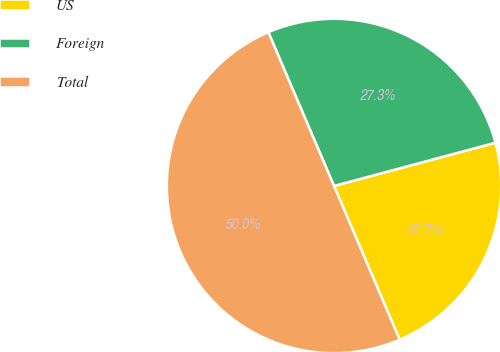Convert chart. <chart><loc_0><loc_0><loc_500><loc_500><pie_chart><fcel>US<fcel>Foreign<fcel>Total<nl><fcel>22.74%<fcel>27.26%<fcel>50.0%<nl></chart> 